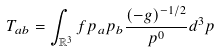<formula> <loc_0><loc_0><loc_500><loc_500>T _ { a b } = \int _ { \mathbb { R } ^ { 3 } } f p _ { a } p _ { b } \frac { ( - g ) ^ { - 1 / 2 } } { p ^ { 0 } } d ^ { 3 } p</formula> 